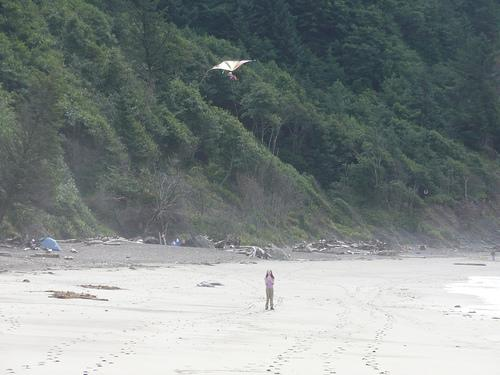What flutters just beneath the main body of this kite? Please explain your reasoning. tail. It has a tail hanging down. 